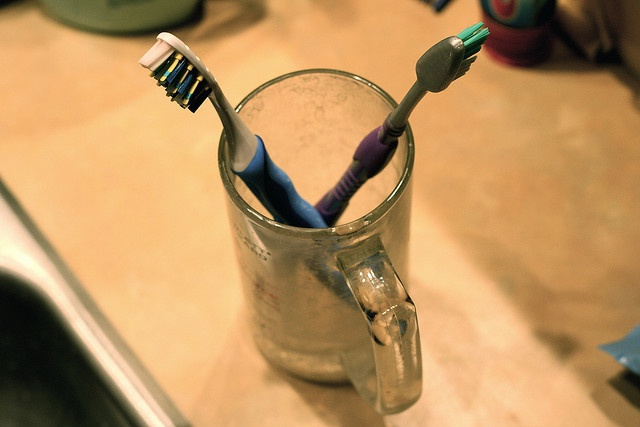Describe the objects in this image and their specific colors. I can see cup in black, tan, and olive tones, sink in black, darkgreen, gray, and tan tones, toothbrush in black, tan, olive, and blue tones, toothbrush in black, darkgreen, and gray tones, and cup in black, maroon, and brown tones in this image. 